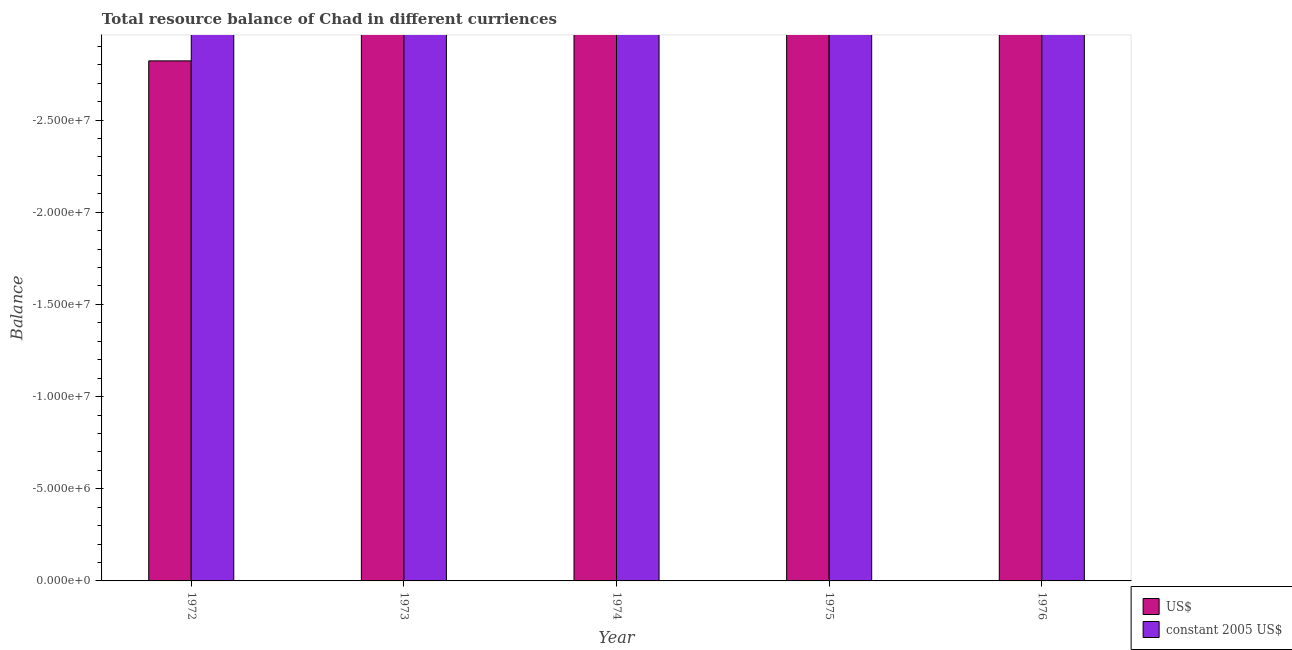Are the number of bars per tick equal to the number of legend labels?
Your response must be concise. No. Are the number of bars on each tick of the X-axis equal?
Make the answer very short. Yes. What is the label of the 4th group of bars from the left?
Keep it short and to the point. 1975. In how many cases, is the number of bars for a given year not equal to the number of legend labels?
Provide a short and direct response. 5. Across all years, what is the minimum resource balance in us$?
Your answer should be compact. 0. What is the total resource balance in us$ in the graph?
Ensure brevity in your answer.  0. What is the difference between the resource balance in us$ in 1975 and the resource balance in constant us$ in 1974?
Your answer should be compact. 0. What is the average resource balance in us$ per year?
Give a very brief answer. 0. In how many years, is the resource balance in us$ greater than -17000000 units?
Give a very brief answer. 0. In how many years, is the resource balance in us$ greater than the average resource balance in us$ taken over all years?
Provide a succinct answer. 0. How many bars are there?
Your answer should be very brief. 0. Are all the bars in the graph horizontal?
Your response must be concise. No. Are the values on the major ticks of Y-axis written in scientific E-notation?
Keep it short and to the point. Yes. Does the graph contain any zero values?
Keep it short and to the point. Yes. Where does the legend appear in the graph?
Ensure brevity in your answer.  Bottom right. What is the title of the graph?
Provide a succinct answer. Total resource balance of Chad in different curriences. Does "Private consumption" appear as one of the legend labels in the graph?
Provide a succinct answer. No. What is the label or title of the Y-axis?
Keep it short and to the point. Balance. What is the Balance of constant 2005 US$ in 1972?
Your response must be concise. 0. What is the Balance in US$ in 1974?
Provide a short and direct response. 0. What is the Balance of US$ in 1976?
Offer a very short reply. 0. 